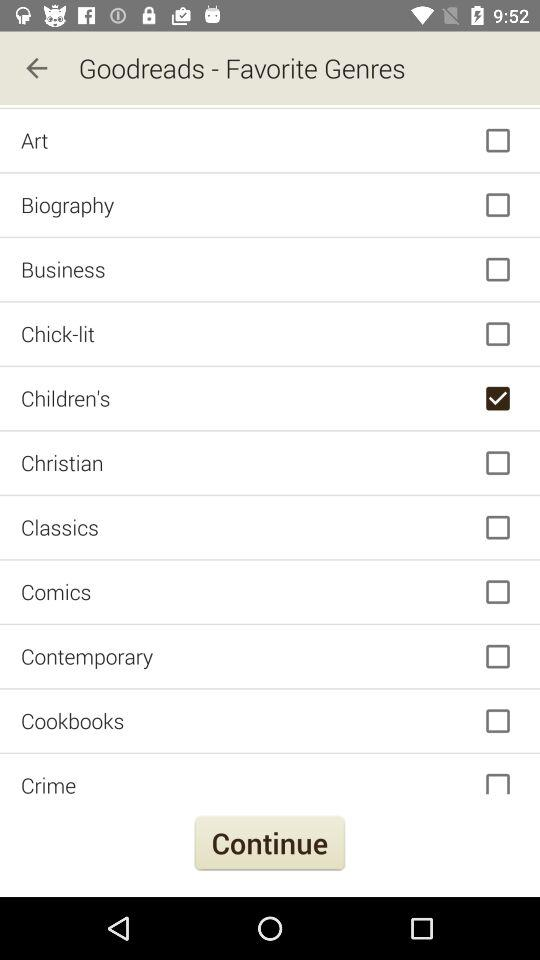What option has been selected? The selected option is "Children's". 